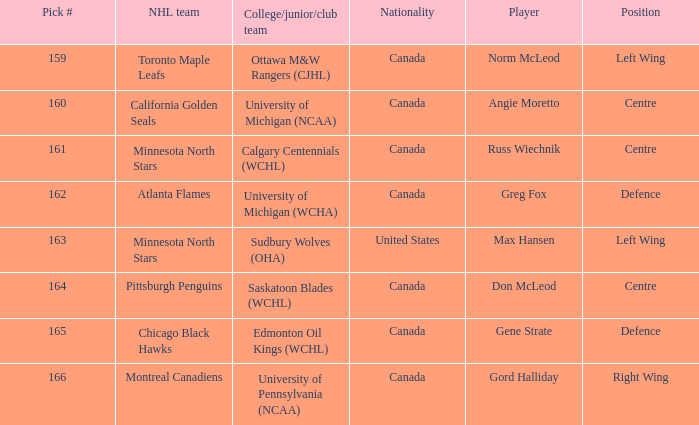What team did Russ Wiechnik, on the centre position, come from? Calgary Centennials (WCHL). 